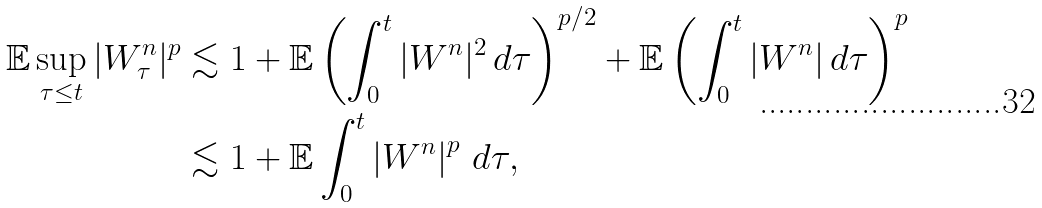Convert formula to latex. <formula><loc_0><loc_0><loc_500><loc_500>\mathbb { E } \sup _ { \tau \leq t } | W _ { \tau } ^ { n } | ^ { p } & \lesssim 1 + \mathbb { E } \left ( \int _ { 0 } ^ { t } | W ^ { n } | ^ { 2 } \, d \tau \right ) ^ { p / 2 } + \mathbb { E } \left ( \int _ { 0 } ^ { t } | W ^ { n } | \, d \tau \right ) ^ { p } \\ & \lesssim 1 + \mathbb { E } \int _ { 0 } ^ { t } \left | W ^ { n } \right | ^ { p } \, d \tau ,</formula> 